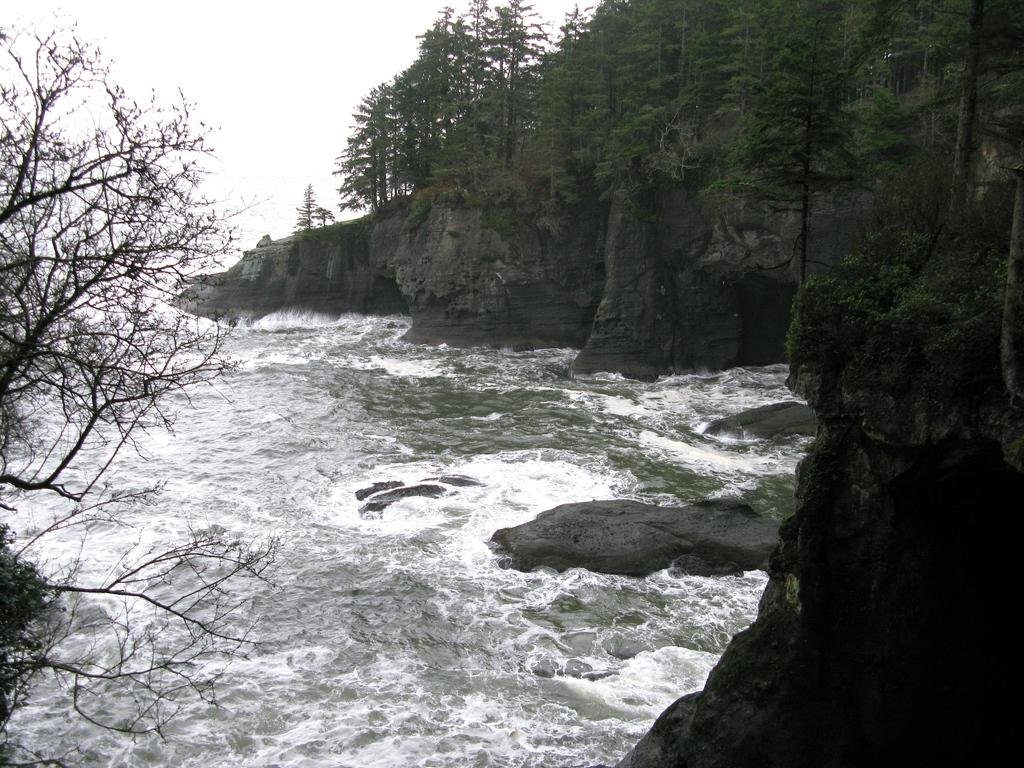What is the primary element visible in the image? There is water in the image. What other objects or features can be seen in the image? There are rocks and trees in the image. How many eggs are visible in the image? There are no eggs present in the image. What type of power source is visible in the image? There is no power source visible in the image. 